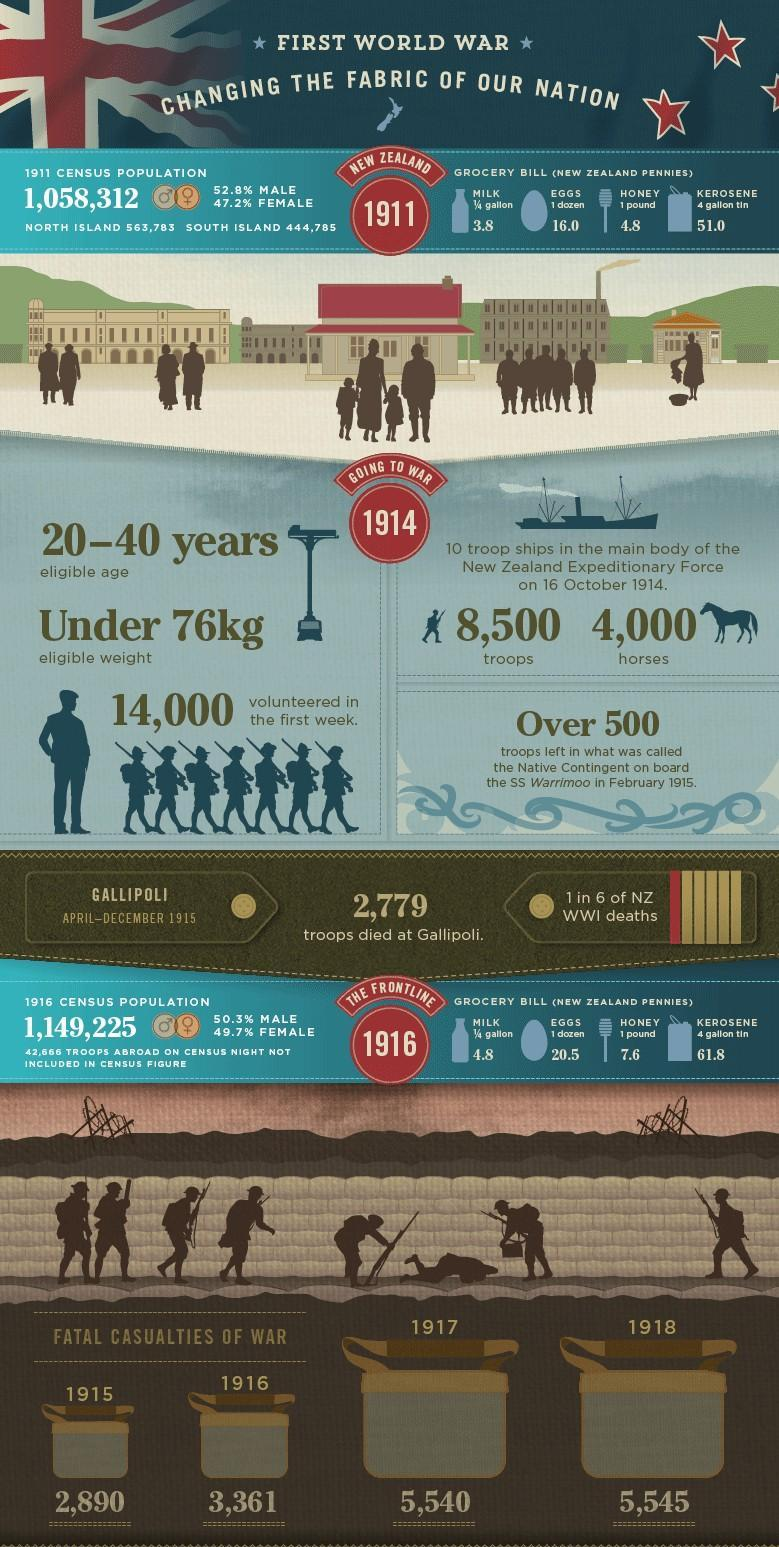what was the total casualties of war in 1917 and 1918 taken together?
Answer the question with a short phrase. 11085 How much did the price of eggs of one dozen  (in New Zealand pennies) increase from 1911 to 1916? 4.5 what was the population of north island according to 1911 census? 563783 How much did the price of kerosene of 4 gallon tln (in New Zealand pennies) increase from 1911 to 1916? 10.8 which year from 1914 to 1918 reported most number of fatal casualties? 1918 what was the price of kerosene of 4 gallon tin (in new Zealand pennies) in 1916? 61.8 what was the percentage of female population in 1916 census? 49.7% what was the total casualties of war from 1915 to 1918 taken together? 17336 what was the total casualties of war in 1915 and 1916 taken together? 6251 How much did the price of milk of 1/4 gallon (in New Zealand pennies) increase from 1911 to 1916? 1 what was the total casualties of war in 1917 and 1916 taken together? 8901 How much did the price of honey of one pound (in New Zealand pennies) increase from 1911 to 1916? 2.8 what was the price of egg of one dozen (in new Zealand pennies) in 1911? 16 